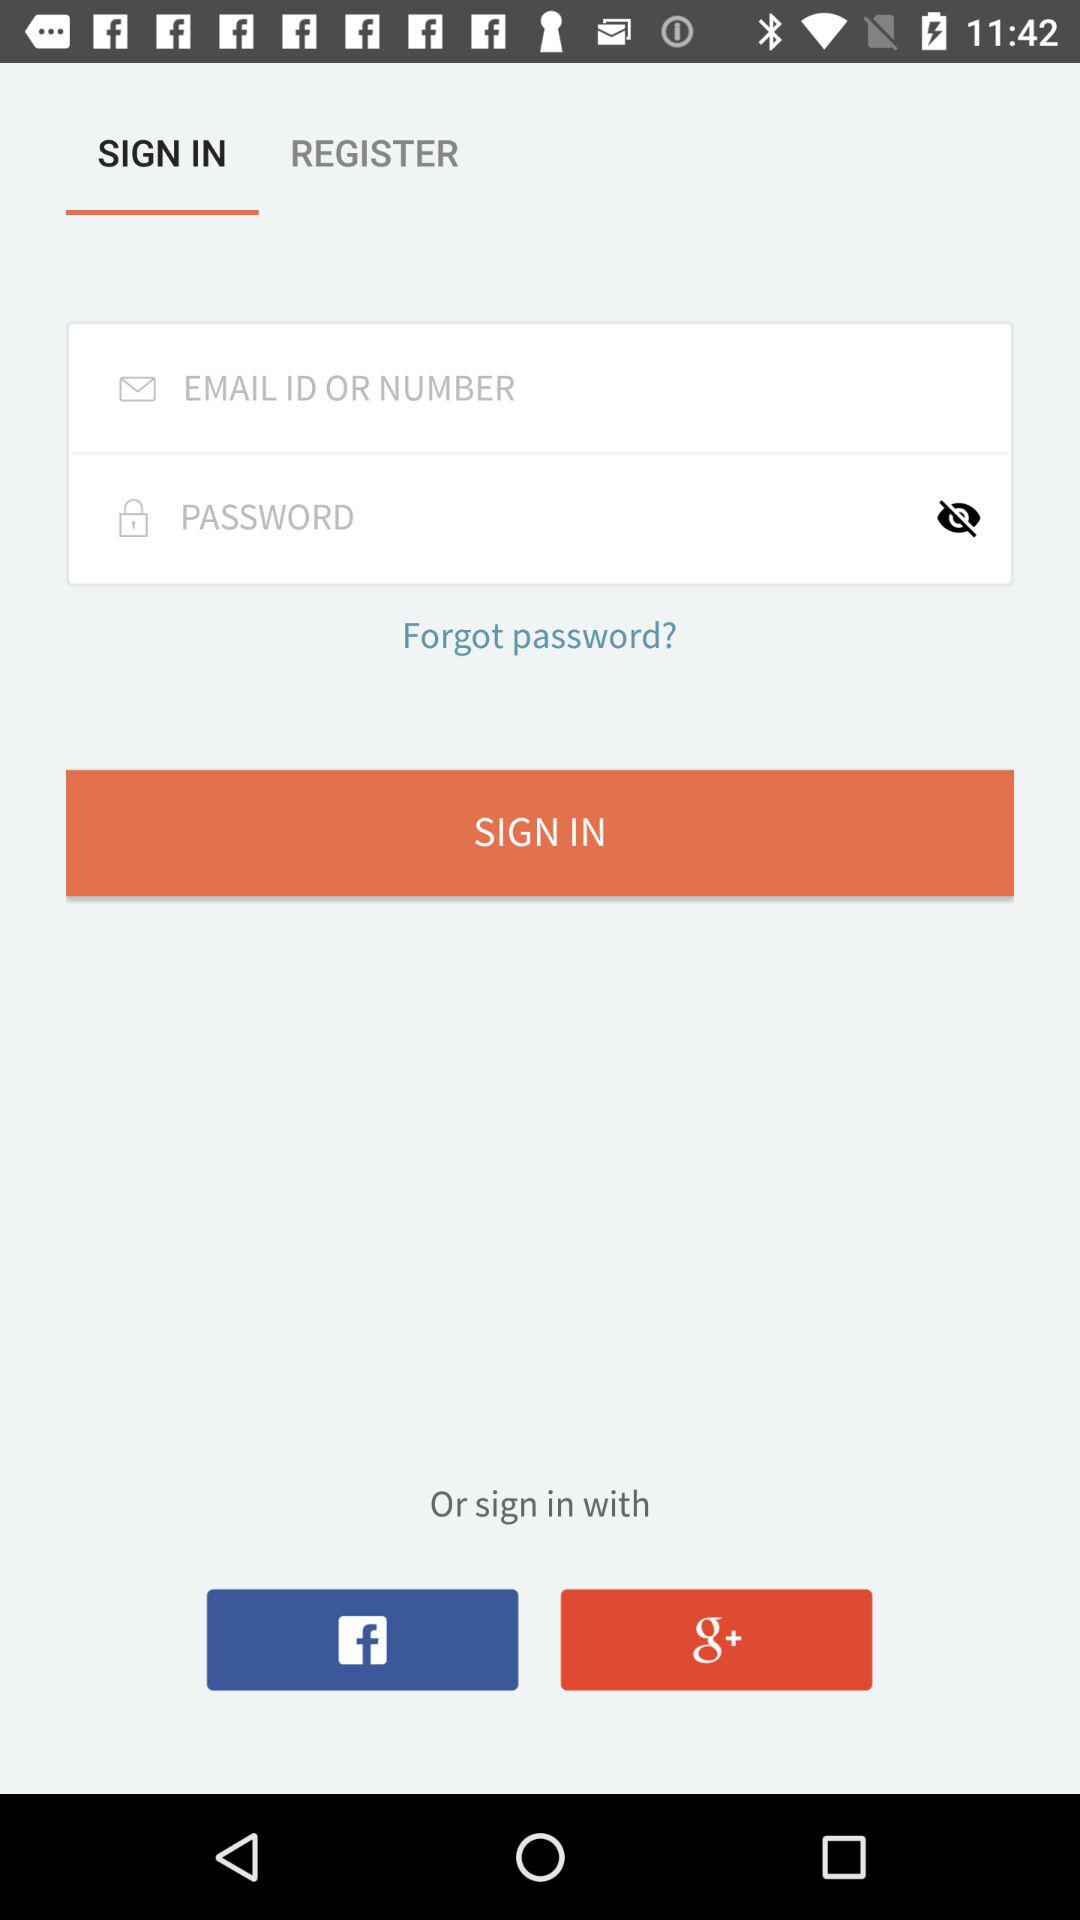What is the entered email ID?
When the provided information is insufficient, respond with <no answer>. <no answer> 